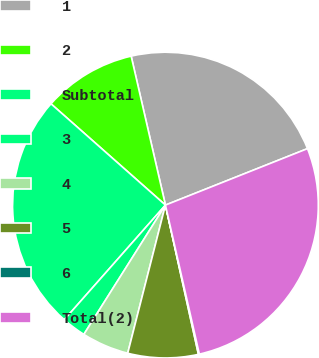<chart> <loc_0><loc_0><loc_500><loc_500><pie_chart><fcel>1<fcel>2<fcel>Subtotal<fcel>3<fcel>4<fcel>5<fcel>6<fcel>Total(2)<nl><fcel>22.58%<fcel>9.87%<fcel>25.02%<fcel>2.55%<fcel>4.99%<fcel>7.43%<fcel>0.1%<fcel>27.46%<nl></chart> 